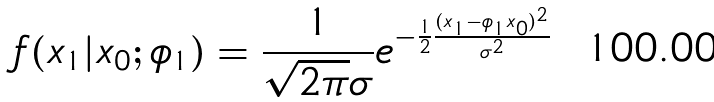<formula> <loc_0><loc_0><loc_500><loc_500>f ( x _ { 1 } | x _ { 0 } ; \phi _ { 1 } ) = \frac { 1 } { \sqrt { 2 \pi } \sigma } e ^ { - \frac { 1 } { 2 } \frac { ( x _ { 1 } - \phi _ { 1 } x _ { 0 } ) ^ { 2 } } { \sigma ^ { 2 } } }</formula> 